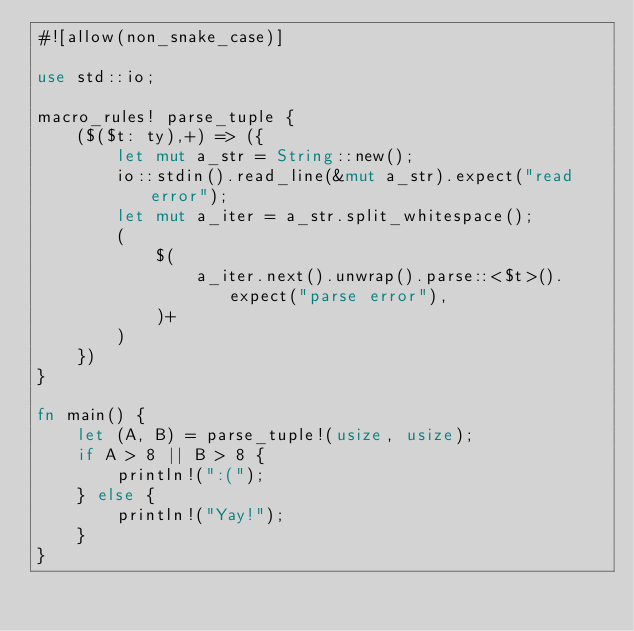Convert code to text. <code><loc_0><loc_0><loc_500><loc_500><_Rust_>#![allow(non_snake_case)]

use std::io;

macro_rules! parse_tuple {
    ($($t: ty),+) => ({
        let mut a_str = String::new();
        io::stdin().read_line(&mut a_str).expect("read error");
        let mut a_iter = a_str.split_whitespace();
        (
            $(
                a_iter.next().unwrap().parse::<$t>().expect("parse error"),
            )+
        )
    })
}

fn main() {
    let (A, B) = parse_tuple!(usize, usize);
    if A > 8 || B > 8 {
        println!(":(");
    } else {
        println!("Yay!");
    }
}</code> 